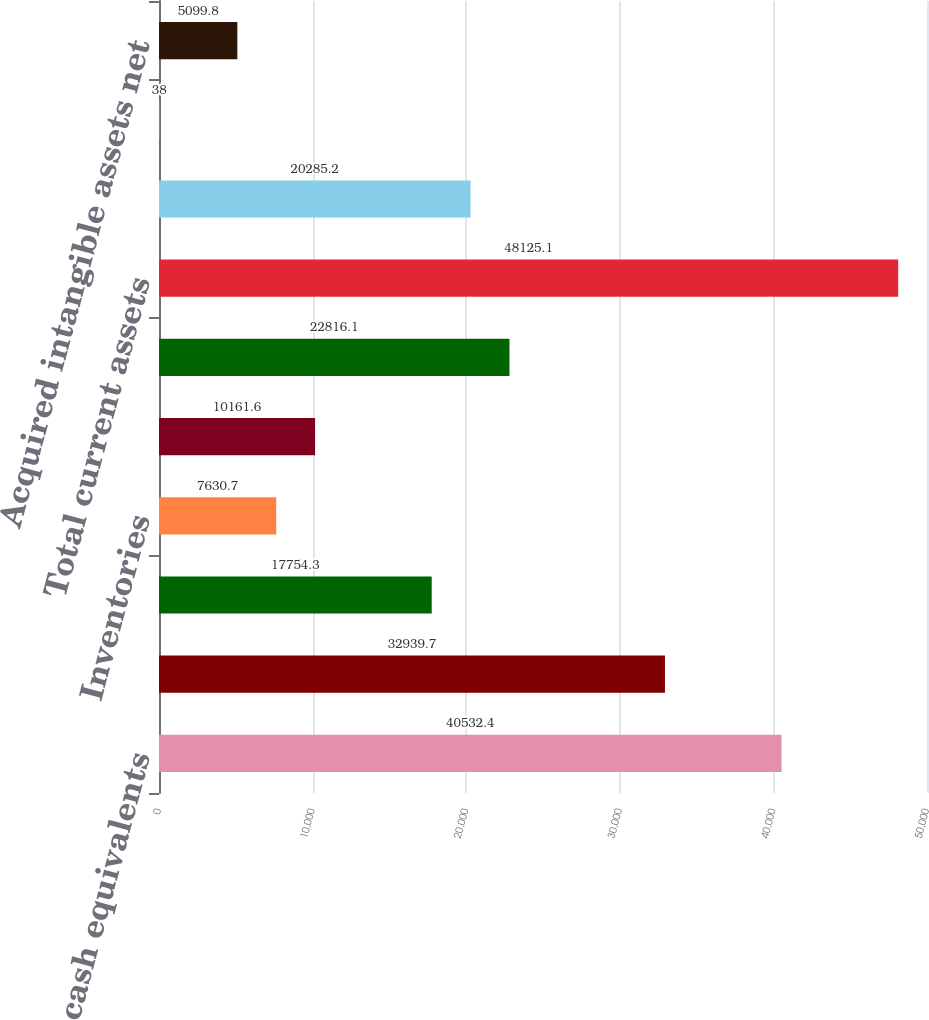<chart> <loc_0><loc_0><loc_500><loc_500><bar_chart><fcel>Cash and cash equivalents<fcel>Short-term investments<fcel>Accounts receivable less<fcel>Inventories<fcel>Deferred tax assets<fcel>Other current assets<fcel>Total current assets<fcel>Property plant and equipment<fcel>Goodwill<fcel>Acquired intangible assets net<nl><fcel>40532.4<fcel>32939.7<fcel>17754.3<fcel>7630.7<fcel>10161.6<fcel>22816.1<fcel>48125.1<fcel>20285.2<fcel>38<fcel>5099.8<nl></chart> 